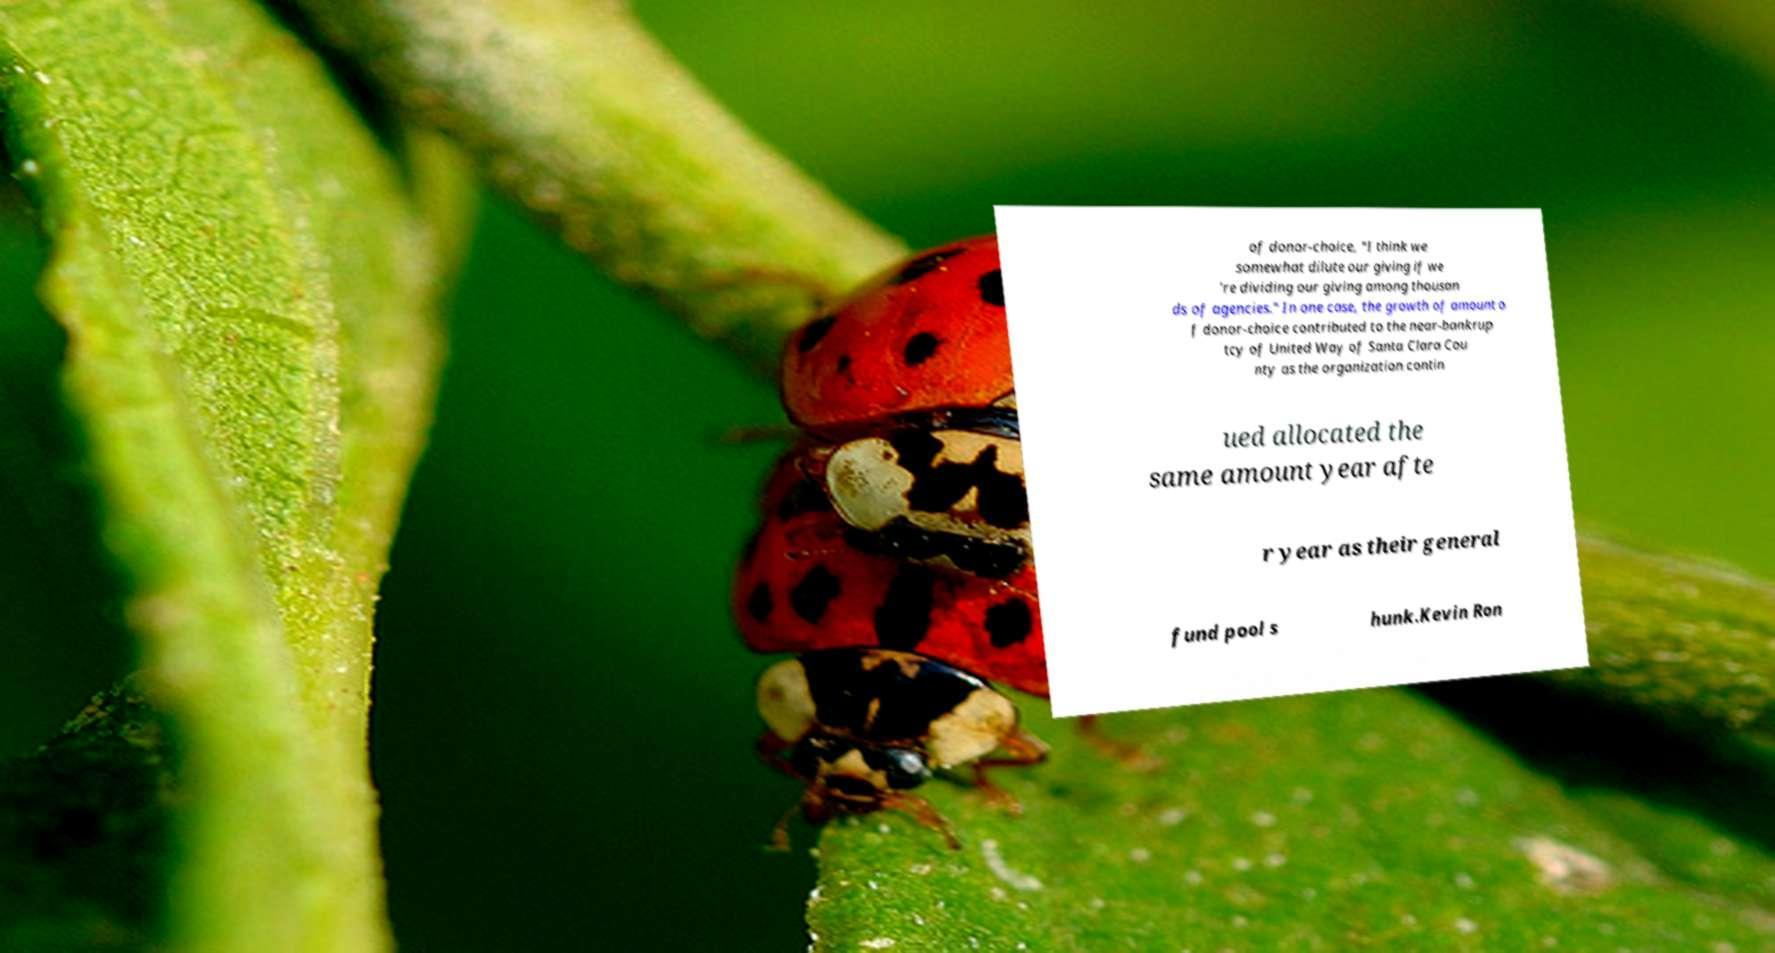What messages or text are displayed in this image? I need them in a readable, typed format. of donor-choice, "I think we somewhat dilute our giving if we 're dividing our giving among thousan ds of agencies." In one case, the growth of amount o f donor-choice contributed to the near-bankrup tcy of United Way of Santa Clara Cou nty as the organization contin ued allocated the same amount year afte r year as their general fund pool s hunk.Kevin Ron 